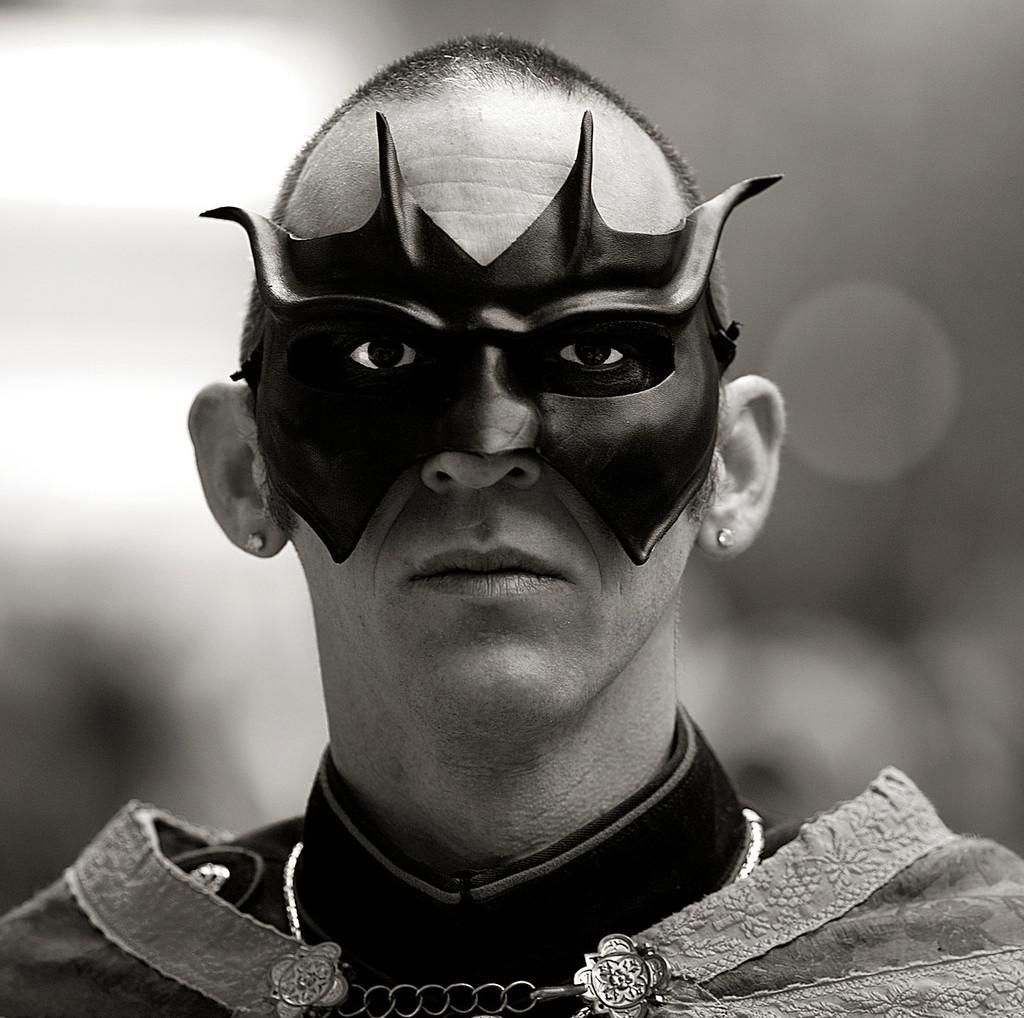What is the color scheme of the image? The image is black and white. Can you describe the person in the image? There is a person in the image, and they are wearing a mask. What can be observed about the background of the image? The background of the image is blurred. What type of kettle is being used to make a selection in the image? There is no kettle or selection process present in the image. What is the ground like in the image? The ground is not visible in the image, as it is focused on the person wearing a mask. 